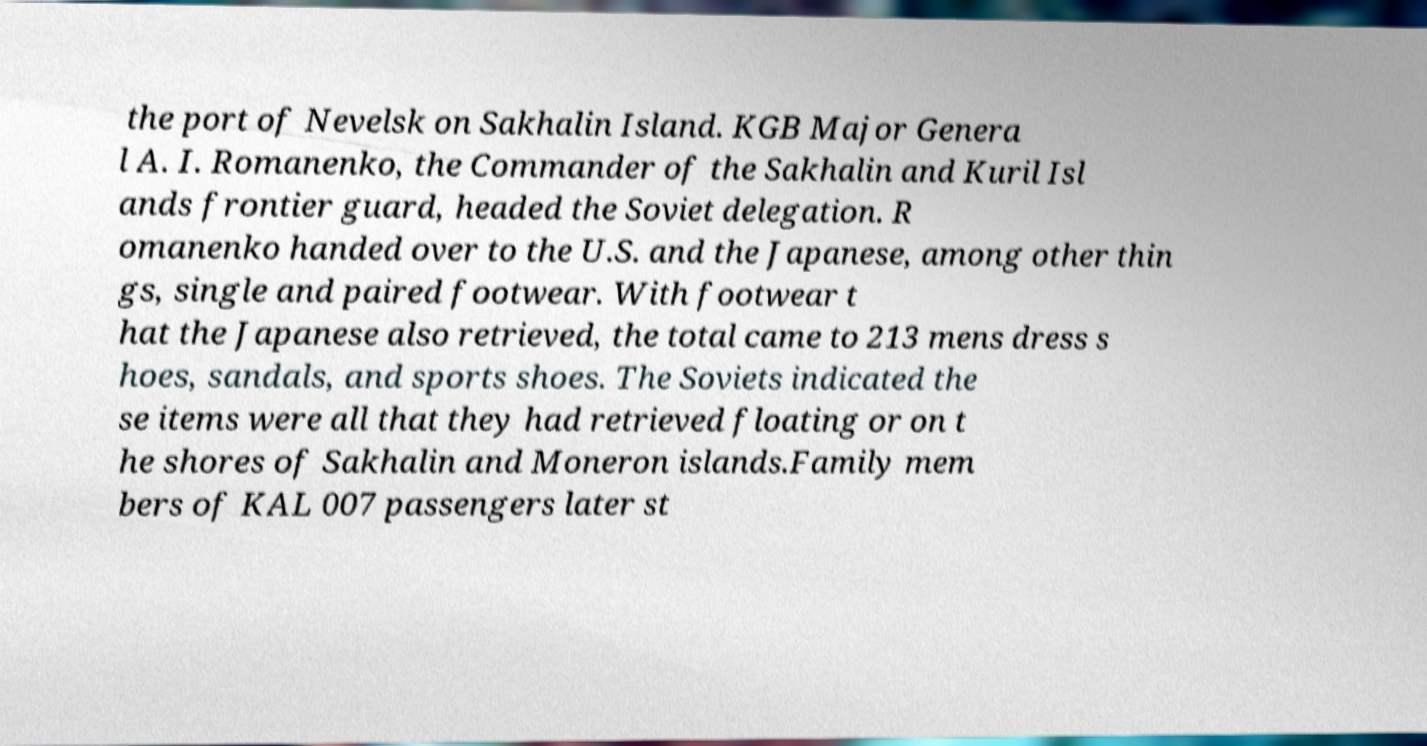For documentation purposes, I need the text within this image transcribed. Could you provide that? the port of Nevelsk on Sakhalin Island. KGB Major Genera l A. I. Romanenko, the Commander of the Sakhalin and Kuril Isl ands frontier guard, headed the Soviet delegation. R omanenko handed over to the U.S. and the Japanese, among other thin gs, single and paired footwear. With footwear t hat the Japanese also retrieved, the total came to 213 mens dress s hoes, sandals, and sports shoes. The Soviets indicated the se items were all that they had retrieved floating or on t he shores of Sakhalin and Moneron islands.Family mem bers of KAL 007 passengers later st 